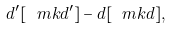<formula> <loc_0><loc_0><loc_500><loc_500>d ^ { \prime } [ \ m k { d } ^ { \prime } ] - d [ \ m k { d } ] ,</formula> 